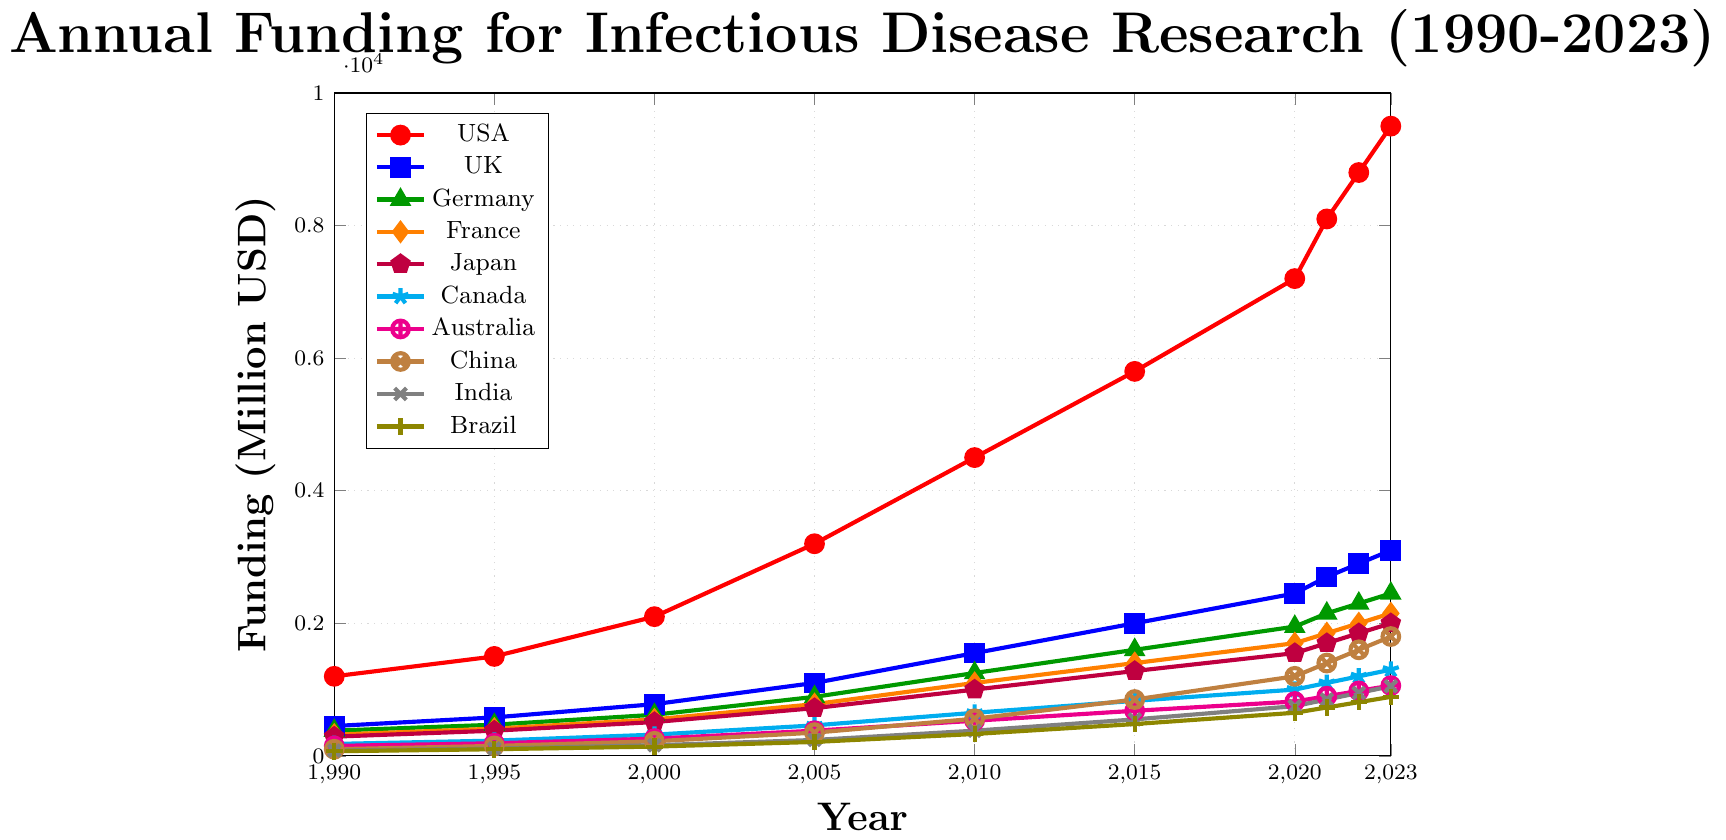Which country had the highest funding in 2023? The line representing the USA reaches the highest value on the y-axis in 2023.
Answer: USA How did the funding of the UK change from 1995 to 2000? In 1995, the UK's funding was 580 million USD, and in 2000, it increased to 780 million USD. The change is 780 - 580 = 200 million USD.
Answer: 200 million USD Which country had the smallest funding in 1990? The line representing Brazil starts at the lowest point on the y-axis in 1990, with a value of 70 million USD.
Answer: Brazil By how much did the funding for China increase from 2015 to 2020? In 2015, China's funding was 850 million USD, and it increased to 1200 million USD by 2020. The difference is 1200 - 850 = 350 million USD.
Answer: 350 million USD What is the average funding for Germany from 1990 to 2023? Add Germany's funding values: 380 + 470 + 620 + 890 + 1250 + 1600 + 1950 + 2150 + 2300 + 2450 = 15060. Then, divide by the number of years (15060 / 10).
Answer: 1506 million USD Which country had the least growth in funding from 1990 to 2023? Brazil had the smallest growth, increasing from 70 million USD in 1990 to 890 million USD in 2023, a difference of 820 million USD.
Answer: Brazil Compare the funding of Japan and France in 2022. In 2022, Japan's funding was 1850 million USD, while France's was 2000 million USD. France's funding was higher.
Answer: France Which year saw the largest increase in funding for the USA? The increase from 2000 (2100 million USD) to 2005 (3200 million USD) is the largest, which is 3200 - 2100 = 1100 million USD.
Answer: 2005 How many countries had funding exceeding 1000 million USD by 2010? By 2010, the USA, UK, Germany, France, and Japan each had funding exceeding 1000 million USD.
Answer: 5 What was the trend for Canada's funding from 1990 to 2023? Canada's funding steadily increased from 180 million USD in 1990 to 1300 million USD in 2023.
Answer: Upward trend 